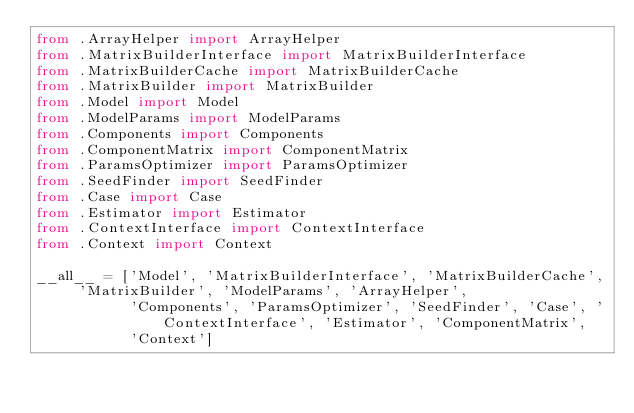Convert code to text. <code><loc_0><loc_0><loc_500><loc_500><_Python_>from .ArrayHelper import ArrayHelper
from .MatrixBuilderInterface import MatrixBuilderInterface
from .MatrixBuilderCache import MatrixBuilderCache
from .MatrixBuilder import MatrixBuilder
from .Model import Model
from .ModelParams import ModelParams
from .Components import Components
from .ComponentMatrix import ComponentMatrix
from .ParamsOptimizer import ParamsOptimizer
from .SeedFinder import SeedFinder
from .Case import Case
from .Estimator import Estimator
from .ContextInterface import ContextInterface
from .Context import Context

__all__ = ['Model', 'MatrixBuilderInterface', 'MatrixBuilderCache', 'MatrixBuilder', 'ModelParams', 'ArrayHelper',
           'Components', 'ParamsOptimizer', 'SeedFinder', 'Case', 'ContextInterface', 'Estimator', 'ComponentMatrix',
           'Context']
</code> 